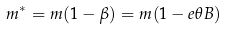<formula> <loc_0><loc_0><loc_500><loc_500>m ^ { * } = m ( 1 - \beta ) = m ( 1 - e \theta B )</formula> 